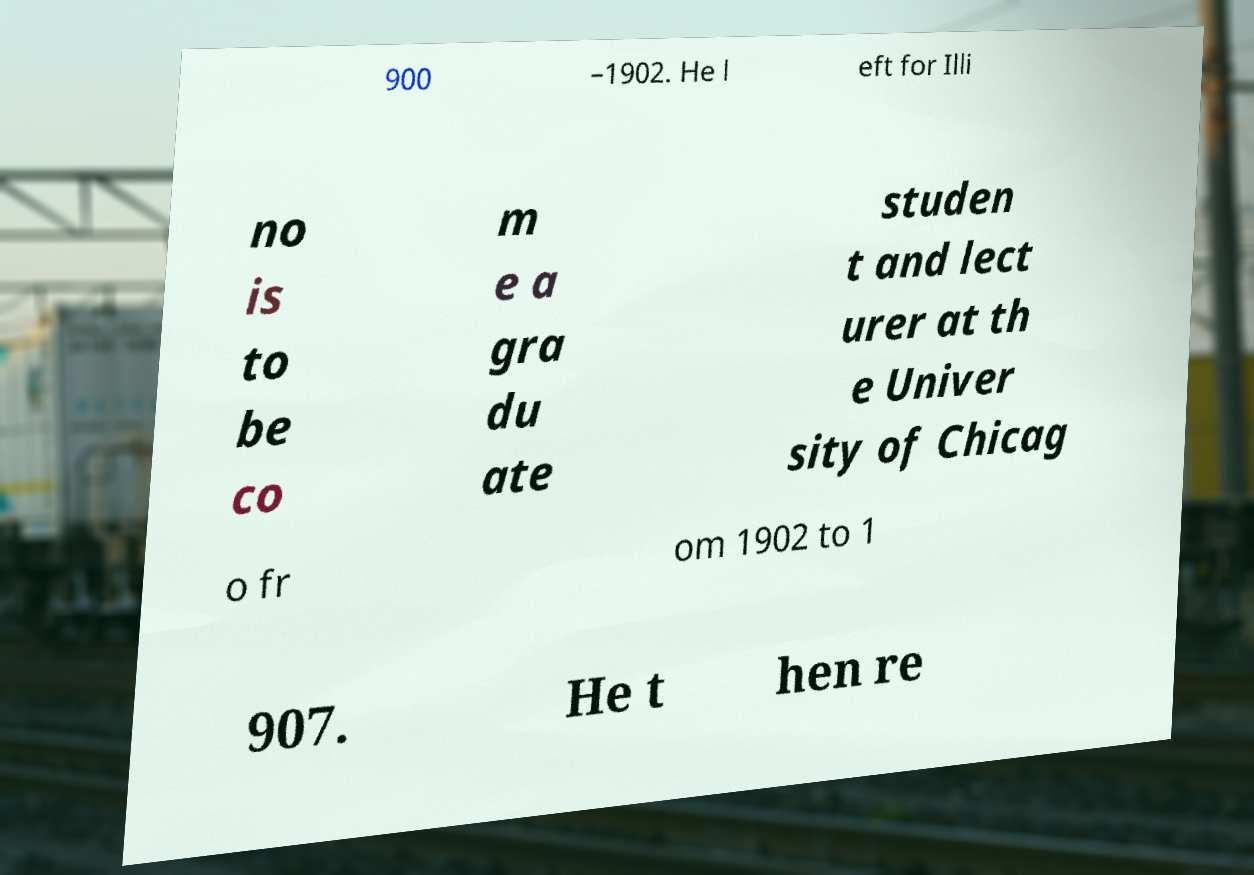There's text embedded in this image that I need extracted. Can you transcribe it verbatim? 900 –1902. He l eft for Illi no is to be co m e a gra du ate studen t and lect urer at th e Univer sity of Chicag o fr om 1902 to 1 907. He t hen re 